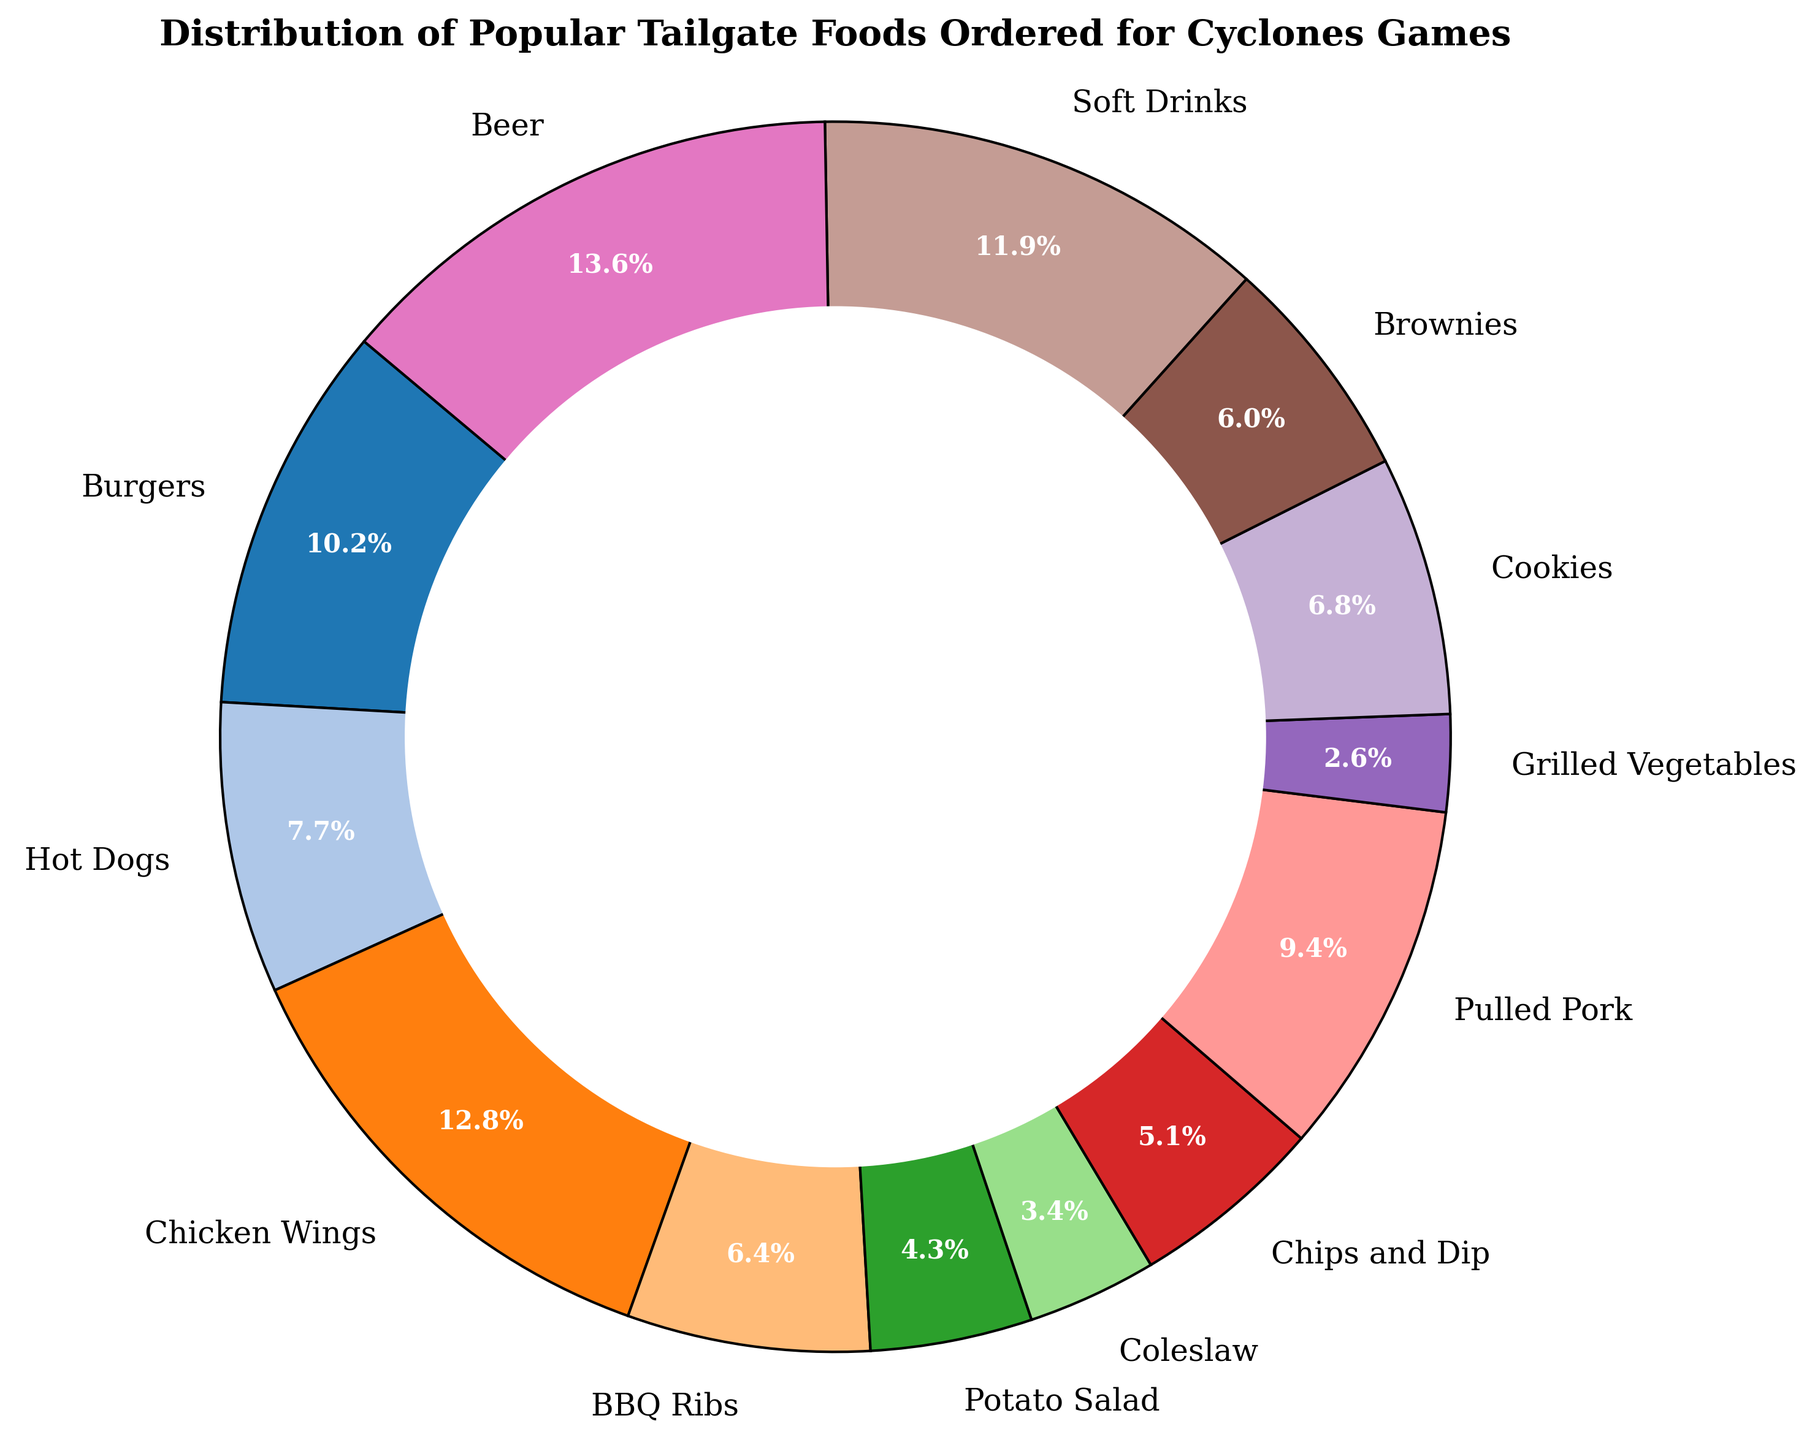Which food item has the highest order count? By looking at the chart, the segment with the largest size corresponds to the food item with the highest order count. Beer has the largest segment.
Answer: Beer Which food item has the lowest order count? By examining the chart, the segment with the smallest size corresponds to the food item with the lowest order count. Grilled Vegetables has the smallest segment.
Answer: Grilled Vegetables How do Soft Drinks compare to Beer in terms of order count? By comparing the segments for Soft Drinks and Beer, the segment for Beer is larger, indicating a higher order count for Beer.
Answer: Beer has a higher order count than Soft Drinks What is the combined order count for Burgers and Hot Dogs? Sum the order counts for Burgers (120) and Hot Dogs (90). 120 + 90 = 210
Answer: 210 Which has more orders: Chicken Wings or BBQ Ribs? By comparing the segments for Chicken Wings and BBQ Ribs, the segment for Chicken Wings is larger.
Answer: Chicken Wings What percentage of the total orders do Chicken Wings represent? The segment for Chicken Wings displays its percentage. By looking at the chart, Chicken Wings represent 19.2% of the total orders.
Answer: 19.2% What is the visual color representation of BBQ Ribs in the pie chart? The pie chart segment for BBQ Ribs has a specific color. Identify this color from the chart.
Answer: (Color of BBQ Ribs segment from the pie chart, e.g., a shade of yellow) How do the order counts for Cookies and Brownies compare? By examining the segments for Cookies and Brownies, Cookies have 80 orders and Brownies have 70 orders. Cookies have a larger segment.
Answer: Cookies have more orders than Brownies What is the combined percentage of orders for Pulled Pork and Chips and Dip? Sum the percentages for Pulled Pork (14.1%) and Chips and Dip (7.7%). 14.1% + 7.7% = 21.8%
Answer: 21.8% Which food items have an order count greater than 100? Look at the order counts provided for each food item and identify those with counts greater than 100: Burgers (120), Chicken Wings (150), Pulled Pork (110), Soft Drinks (140), Beer (160).
Answer: Burgers, Chicken Wings, Pulled Pork, Soft Drinks, Beer 